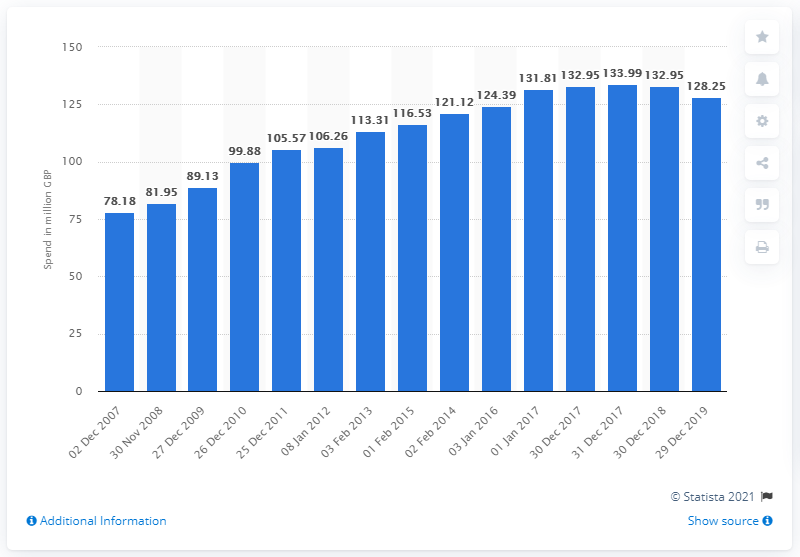Point out several critical features in this image. In the 52-week period ending on December 2nd, 2007, an estimated amount of 132.95 pounds was spent on fresh soup in the UK. 